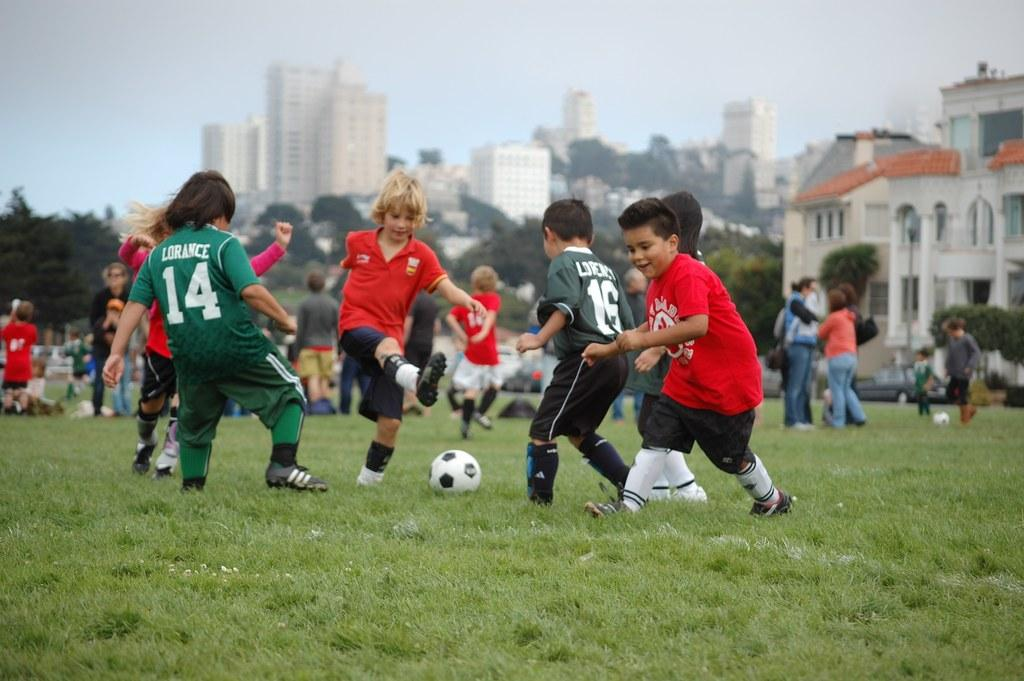Provide a one-sentence caption for the provided image. some kids playing soccer and one with the number 14. 